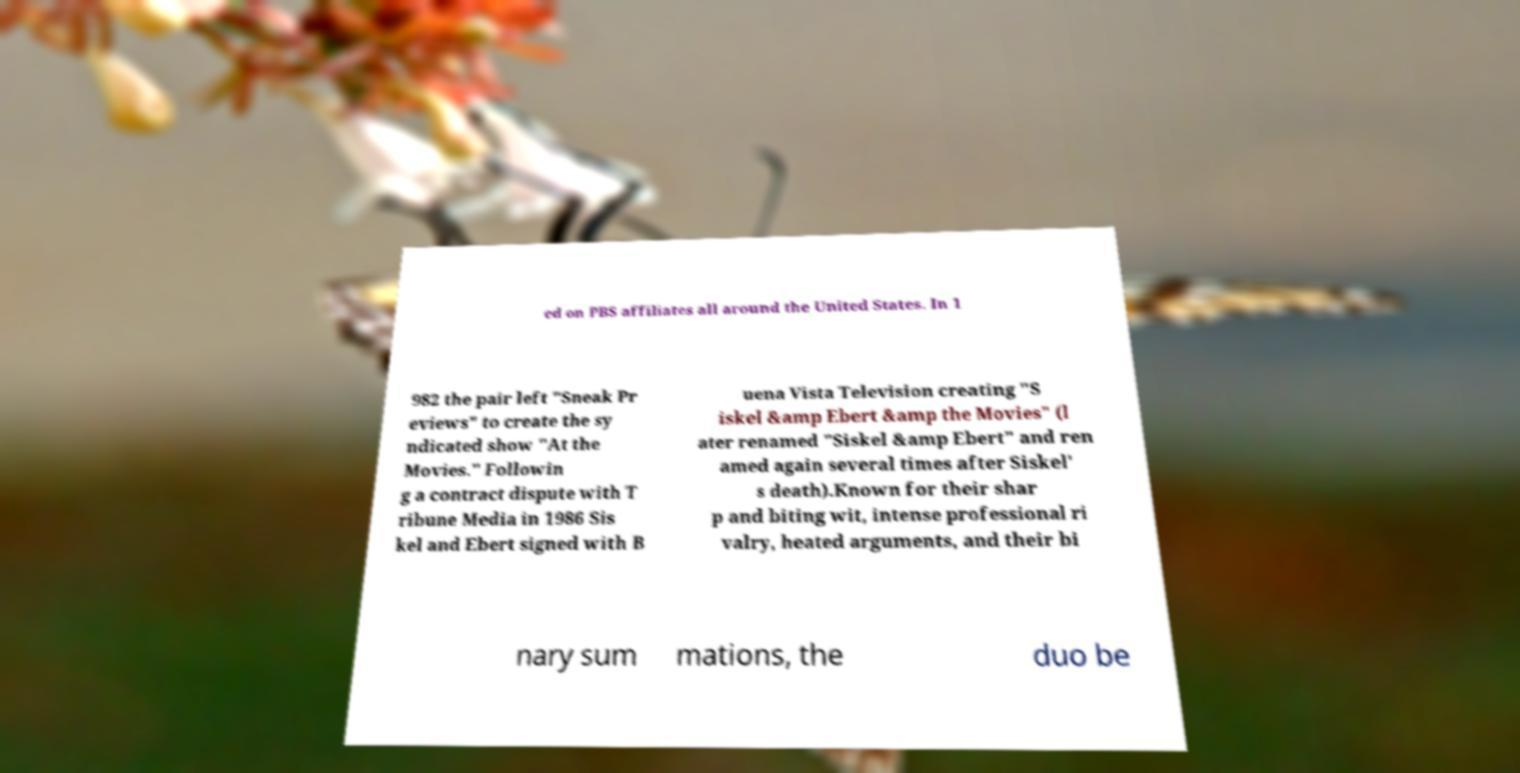What messages or text are displayed in this image? I need them in a readable, typed format. ed on PBS affiliates all around the United States. In 1 982 the pair left "Sneak Pr eviews" to create the sy ndicated show "At the Movies." Followin g a contract dispute with T ribune Media in 1986 Sis kel and Ebert signed with B uena Vista Television creating "S iskel &amp Ebert &amp the Movies" (l ater renamed "Siskel &amp Ebert" and ren amed again several times after Siskel' s death).Known for their shar p and biting wit, intense professional ri valry, heated arguments, and their bi nary sum mations, the duo be 